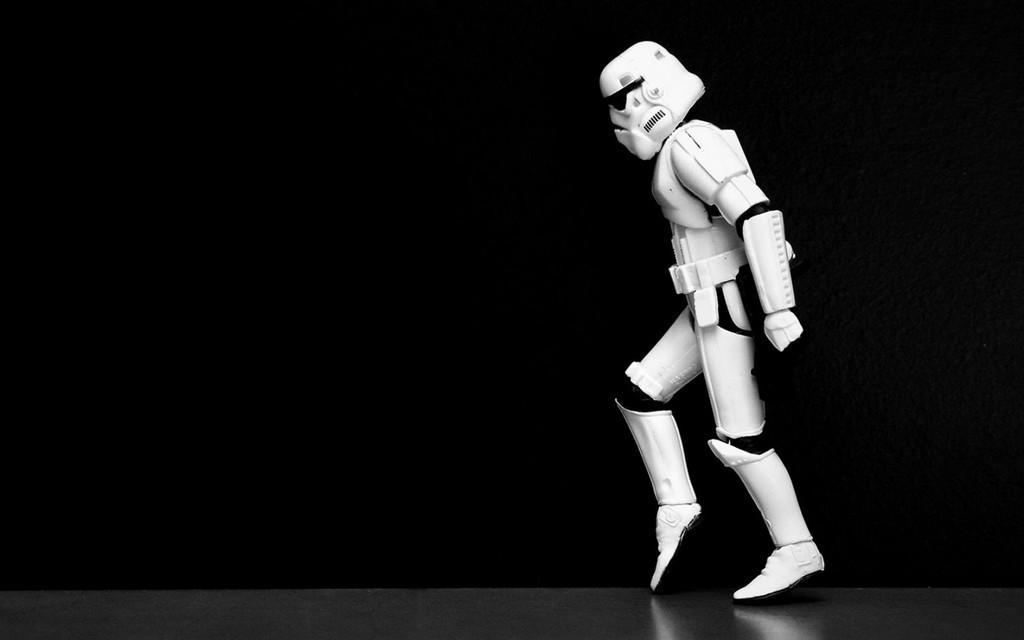What character is present in the image? There is a stormtrooper in the image. What is the color scheme of the background in the image? The background of the image is dark. What type of profit can be seen in the image? There is no profit present in the image; it features a stormtrooper. Can you tell me where the toothbrush is located in the image? There is no toothbrush present in the image. 